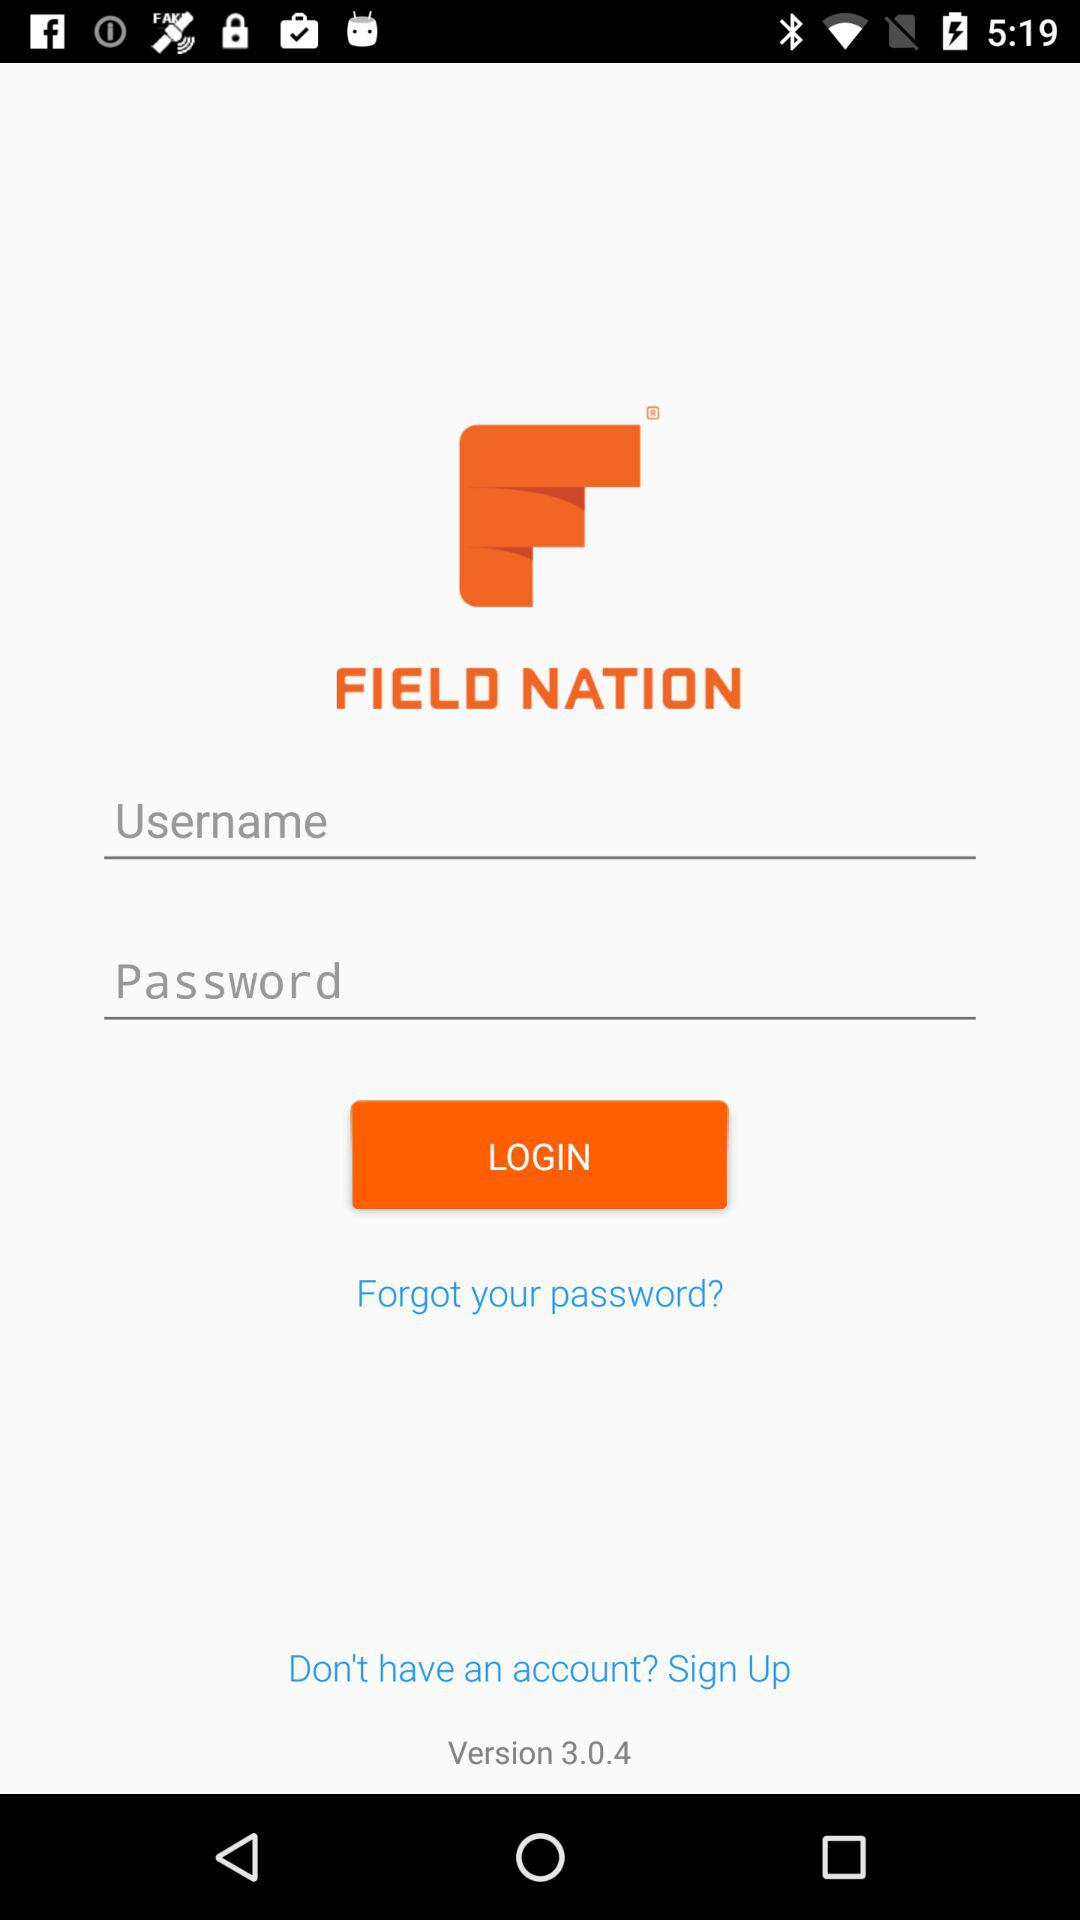Which username is used to log in?
When the provided information is insufficient, respond with <no answer>. <no answer> 